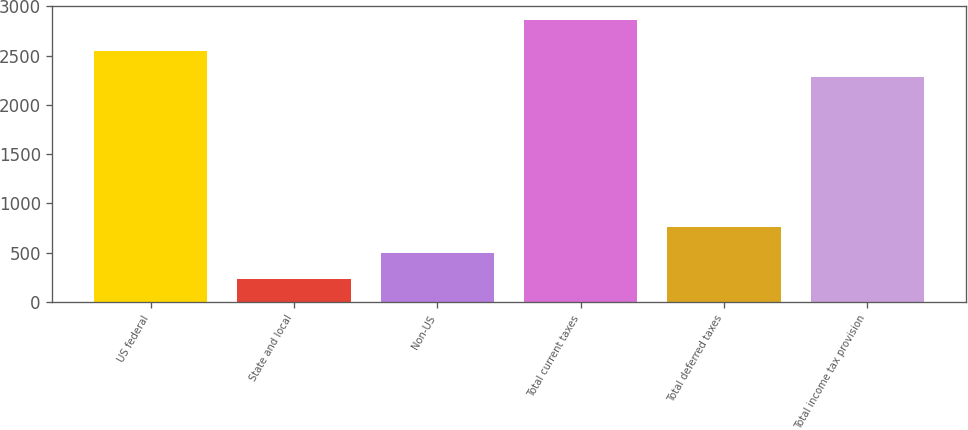Convert chart. <chart><loc_0><loc_0><loc_500><loc_500><bar_chart><fcel>US federal<fcel>State and local<fcel>Non-US<fcel>Total current taxes<fcel>Total deferred taxes<fcel>Total income tax provision<nl><fcel>2548.7<fcel>237<fcel>499.7<fcel>2864<fcel>762.4<fcel>2286<nl></chart> 